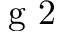<formula> <loc_0><loc_0><loc_500><loc_500>g 2</formula> 